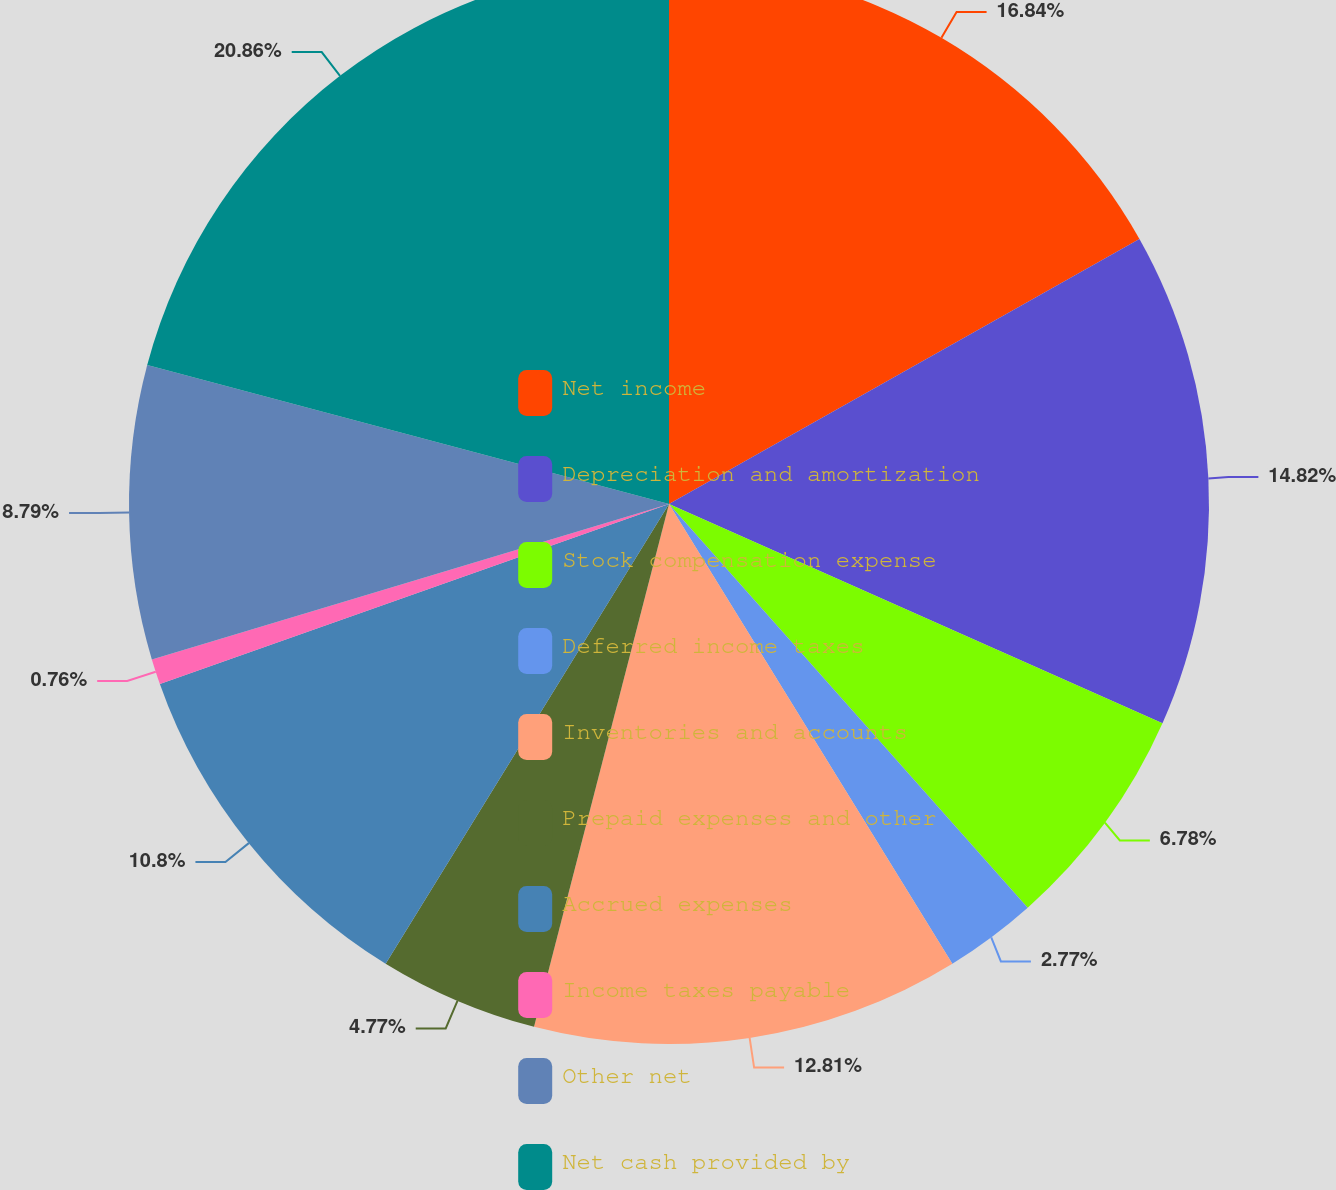Convert chart. <chart><loc_0><loc_0><loc_500><loc_500><pie_chart><fcel>Net income<fcel>Depreciation and amortization<fcel>Stock compensation expense<fcel>Deferred income taxes<fcel>Inventories and accounts<fcel>Prepaid expenses and other<fcel>Accrued expenses<fcel>Income taxes payable<fcel>Other net<fcel>Net cash provided by<nl><fcel>16.83%<fcel>14.82%<fcel>6.78%<fcel>2.77%<fcel>12.81%<fcel>4.77%<fcel>10.8%<fcel>0.76%<fcel>8.79%<fcel>20.85%<nl></chart> 